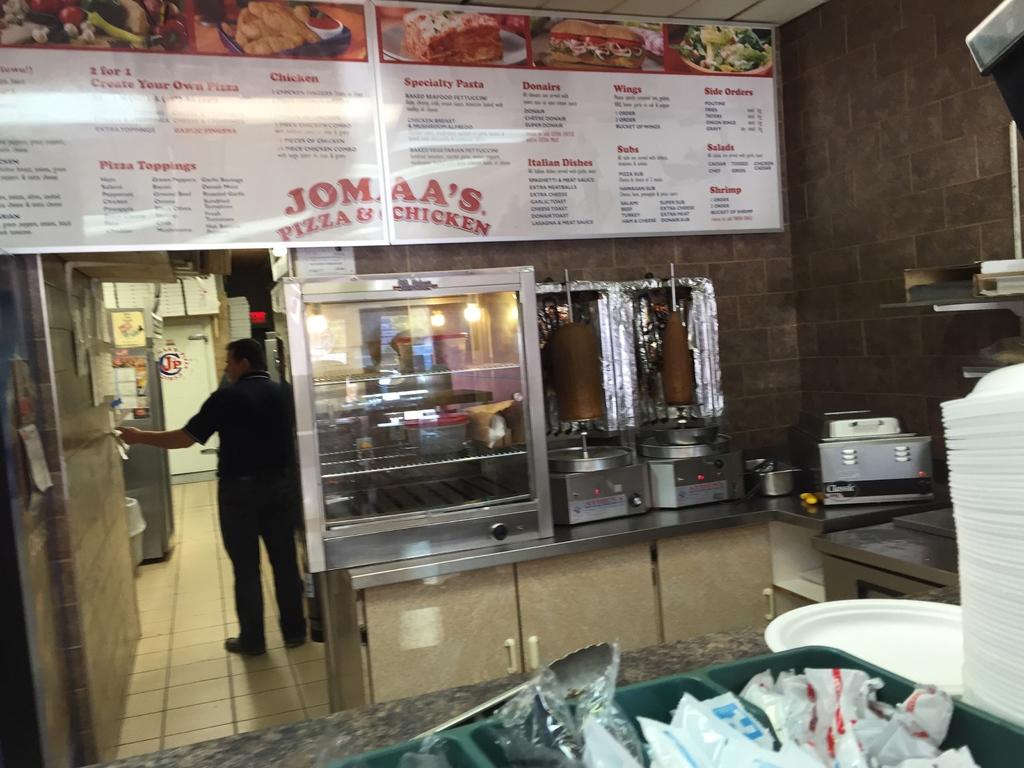What food does this place serve?
Your response must be concise. Pizza & chicken. What is the name of this establishment?
Your answer should be very brief. Jomaa's. 